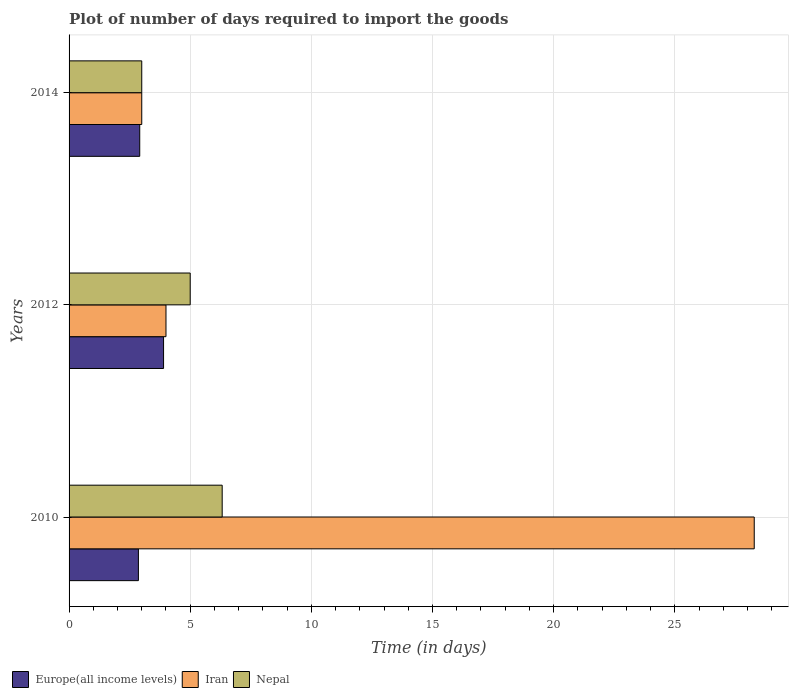Are the number of bars on each tick of the Y-axis equal?
Offer a very short reply. Yes. How many bars are there on the 1st tick from the top?
Give a very brief answer. 3. What is the time required to import goods in Europe(all income levels) in 2010?
Your answer should be very brief. 2.86. Across all years, what is the maximum time required to import goods in Nepal?
Ensure brevity in your answer.  6.32. Across all years, what is the minimum time required to import goods in Europe(all income levels)?
Ensure brevity in your answer.  2.86. What is the total time required to import goods in Nepal in the graph?
Your response must be concise. 14.32. What is the difference between the time required to import goods in Nepal in 2012 and that in 2014?
Make the answer very short. 2. What is the difference between the time required to import goods in Europe(all income levels) in 2010 and the time required to import goods in Nepal in 2012?
Offer a terse response. -2.14. What is the average time required to import goods in Nepal per year?
Your answer should be compact. 4.77. In the year 2014, what is the difference between the time required to import goods in Iran and time required to import goods in Europe(all income levels)?
Ensure brevity in your answer.  0.08. In how many years, is the time required to import goods in Nepal greater than 12 days?
Your answer should be compact. 0. What is the ratio of the time required to import goods in Nepal in 2010 to that in 2014?
Your answer should be compact. 2.11. Is the time required to import goods in Nepal in 2010 less than that in 2014?
Make the answer very short. No. What is the difference between the highest and the second highest time required to import goods in Nepal?
Ensure brevity in your answer.  1.32. What is the difference between the highest and the lowest time required to import goods in Iran?
Offer a terse response. 25.28. In how many years, is the time required to import goods in Nepal greater than the average time required to import goods in Nepal taken over all years?
Keep it short and to the point. 2. What does the 3rd bar from the top in 2012 represents?
Your response must be concise. Europe(all income levels). What does the 2nd bar from the bottom in 2012 represents?
Offer a very short reply. Iran. Is it the case that in every year, the sum of the time required to import goods in Europe(all income levels) and time required to import goods in Nepal is greater than the time required to import goods in Iran?
Give a very brief answer. No. How many years are there in the graph?
Provide a succinct answer. 3. Are the values on the major ticks of X-axis written in scientific E-notation?
Provide a short and direct response. No. Where does the legend appear in the graph?
Ensure brevity in your answer.  Bottom left. How are the legend labels stacked?
Make the answer very short. Horizontal. What is the title of the graph?
Your answer should be compact. Plot of number of days required to import the goods. Does "Burundi" appear as one of the legend labels in the graph?
Offer a terse response. No. What is the label or title of the X-axis?
Provide a short and direct response. Time (in days). What is the label or title of the Y-axis?
Offer a very short reply. Years. What is the Time (in days) in Europe(all income levels) in 2010?
Give a very brief answer. 2.86. What is the Time (in days) of Iran in 2010?
Your answer should be compact. 28.28. What is the Time (in days) of Nepal in 2010?
Your answer should be compact. 6.32. What is the Time (in days) in Nepal in 2012?
Your answer should be compact. 5. What is the Time (in days) of Europe(all income levels) in 2014?
Your answer should be very brief. 2.92. What is the Time (in days) of Iran in 2014?
Offer a terse response. 3. Across all years, what is the maximum Time (in days) in Iran?
Give a very brief answer. 28.28. Across all years, what is the maximum Time (in days) of Nepal?
Offer a very short reply. 6.32. Across all years, what is the minimum Time (in days) in Europe(all income levels)?
Your response must be concise. 2.86. Across all years, what is the minimum Time (in days) in Nepal?
Ensure brevity in your answer.  3. What is the total Time (in days) in Europe(all income levels) in the graph?
Ensure brevity in your answer.  9.68. What is the total Time (in days) of Iran in the graph?
Provide a succinct answer. 35.28. What is the total Time (in days) in Nepal in the graph?
Your response must be concise. 14.32. What is the difference between the Time (in days) of Europe(all income levels) in 2010 and that in 2012?
Your answer should be very brief. -1.04. What is the difference between the Time (in days) in Iran in 2010 and that in 2012?
Your answer should be very brief. 24.28. What is the difference between the Time (in days) in Nepal in 2010 and that in 2012?
Offer a very short reply. 1.32. What is the difference between the Time (in days) in Europe(all income levels) in 2010 and that in 2014?
Offer a terse response. -0.05. What is the difference between the Time (in days) of Iran in 2010 and that in 2014?
Offer a terse response. 25.28. What is the difference between the Time (in days) in Nepal in 2010 and that in 2014?
Offer a terse response. 3.32. What is the difference between the Time (in days) of Europe(all income levels) in 2012 and that in 2014?
Offer a very short reply. 0.98. What is the difference between the Time (in days) in Europe(all income levels) in 2010 and the Time (in days) in Iran in 2012?
Your answer should be very brief. -1.14. What is the difference between the Time (in days) in Europe(all income levels) in 2010 and the Time (in days) in Nepal in 2012?
Keep it short and to the point. -2.14. What is the difference between the Time (in days) of Iran in 2010 and the Time (in days) of Nepal in 2012?
Offer a terse response. 23.28. What is the difference between the Time (in days) of Europe(all income levels) in 2010 and the Time (in days) of Iran in 2014?
Offer a terse response. -0.14. What is the difference between the Time (in days) of Europe(all income levels) in 2010 and the Time (in days) of Nepal in 2014?
Provide a succinct answer. -0.14. What is the difference between the Time (in days) in Iran in 2010 and the Time (in days) in Nepal in 2014?
Your answer should be compact. 25.28. What is the difference between the Time (in days) of Europe(all income levels) in 2012 and the Time (in days) of Iran in 2014?
Offer a terse response. 0.9. What is the difference between the Time (in days) of Iran in 2012 and the Time (in days) of Nepal in 2014?
Your answer should be very brief. 1. What is the average Time (in days) in Europe(all income levels) per year?
Your answer should be compact. 3.23. What is the average Time (in days) of Iran per year?
Offer a terse response. 11.76. What is the average Time (in days) in Nepal per year?
Provide a succinct answer. 4.77. In the year 2010, what is the difference between the Time (in days) in Europe(all income levels) and Time (in days) in Iran?
Provide a succinct answer. -25.42. In the year 2010, what is the difference between the Time (in days) in Europe(all income levels) and Time (in days) in Nepal?
Offer a terse response. -3.46. In the year 2010, what is the difference between the Time (in days) of Iran and Time (in days) of Nepal?
Ensure brevity in your answer.  21.96. In the year 2012, what is the difference between the Time (in days) in Iran and Time (in days) in Nepal?
Offer a terse response. -1. In the year 2014, what is the difference between the Time (in days) of Europe(all income levels) and Time (in days) of Iran?
Give a very brief answer. -0.08. In the year 2014, what is the difference between the Time (in days) of Europe(all income levels) and Time (in days) of Nepal?
Give a very brief answer. -0.08. What is the ratio of the Time (in days) of Europe(all income levels) in 2010 to that in 2012?
Your response must be concise. 0.73. What is the ratio of the Time (in days) in Iran in 2010 to that in 2012?
Provide a succinct answer. 7.07. What is the ratio of the Time (in days) in Nepal in 2010 to that in 2012?
Your response must be concise. 1.26. What is the ratio of the Time (in days) in Europe(all income levels) in 2010 to that in 2014?
Provide a short and direct response. 0.98. What is the ratio of the Time (in days) in Iran in 2010 to that in 2014?
Keep it short and to the point. 9.43. What is the ratio of the Time (in days) of Nepal in 2010 to that in 2014?
Your answer should be very brief. 2.11. What is the ratio of the Time (in days) of Europe(all income levels) in 2012 to that in 2014?
Provide a succinct answer. 1.34. What is the ratio of the Time (in days) of Iran in 2012 to that in 2014?
Offer a very short reply. 1.33. What is the ratio of the Time (in days) of Nepal in 2012 to that in 2014?
Make the answer very short. 1.67. What is the difference between the highest and the second highest Time (in days) in Europe(all income levels)?
Give a very brief answer. 0.98. What is the difference between the highest and the second highest Time (in days) of Iran?
Your answer should be very brief. 24.28. What is the difference between the highest and the second highest Time (in days) of Nepal?
Your answer should be very brief. 1.32. What is the difference between the highest and the lowest Time (in days) of Europe(all income levels)?
Your answer should be compact. 1.04. What is the difference between the highest and the lowest Time (in days) of Iran?
Your answer should be very brief. 25.28. What is the difference between the highest and the lowest Time (in days) in Nepal?
Offer a very short reply. 3.32. 